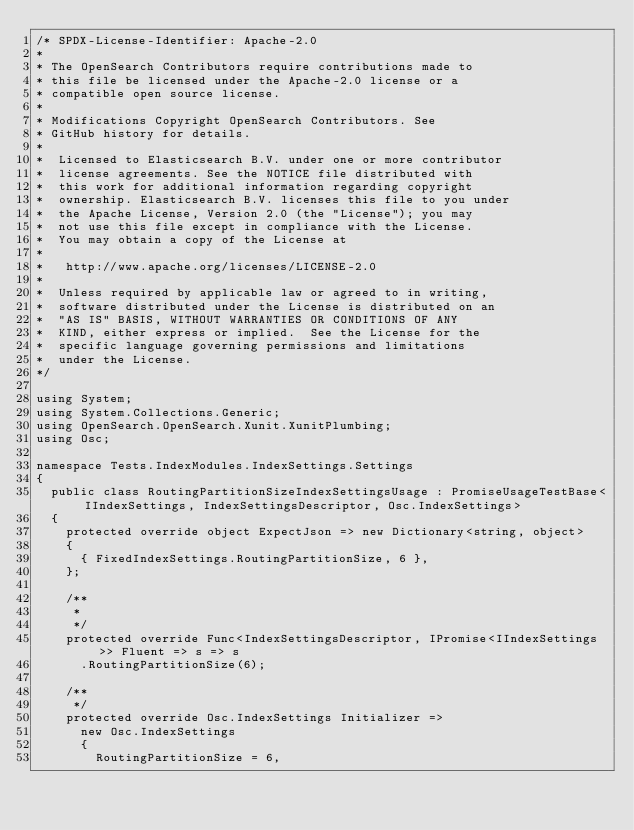Convert code to text. <code><loc_0><loc_0><loc_500><loc_500><_C#_>/* SPDX-License-Identifier: Apache-2.0
*
* The OpenSearch Contributors require contributions made to
* this file be licensed under the Apache-2.0 license or a
* compatible open source license.
*
* Modifications Copyright OpenSearch Contributors. See
* GitHub history for details.
*
*  Licensed to Elasticsearch B.V. under one or more contributor
*  license agreements. See the NOTICE file distributed with
*  this work for additional information regarding copyright
*  ownership. Elasticsearch B.V. licenses this file to you under
*  the Apache License, Version 2.0 (the "License"); you may
*  not use this file except in compliance with the License.
*  You may obtain a copy of the License at
*
* 	http://www.apache.org/licenses/LICENSE-2.0
*
*  Unless required by applicable law or agreed to in writing,
*  software distributed under the License is distributed on an
*  "AS IS" BASIS, WITHOUT WARRANTIES OR CONDITIONS OF ANY
*  KIND, either express or implied.  See the License for the
*  specific language governing permissions and limitations
*  under the License.
*/

using System;
using System.Collections.Generic;
using OpenSearch.OpenSearch.Xunit.XunitPlumbing;
using Osc;

namespace Tests.IndexModules.IndexSettings.Settings
{
	public class RoutingPartitionSizeIndexSettingsUsage : PromiseUsageTestBase<IIndexSettings, IndexSettingsDescriptor, Osc.IndexSettings>
	{
		protected override object ExpectJson => new Dictionary<string, object>
		{
			{ FixedIndexSettings.RoutingPartitionSize, 6 },
		};

		/**
		 *
		 */
		protected override Func<IndexSettingsDescriptor, IPromise<IIndexSettings>> Fluent => s => s
			.RoutingPartitionSize(6);

		/**
		 */
		protected override Osc.IndexSettings Initializer =>
			new Osc.IndexSettings
			{
				RoutingPartitionSize = 6,</code> 